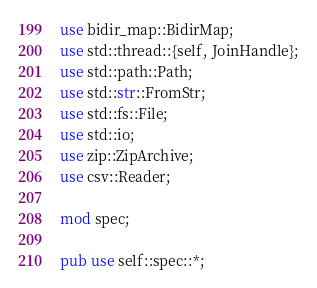Convert code to text. <code><loc_0><loc_0><loc_500><loc_500><_Rust_>use bidir_map::BidirMap;
use std::thread::{self, JoinHandle};
use std::path::Path;
use std::str::FromStr;
use std::fs::File;
use std::io;
use zip::ZipArchive;
use csv::Reader;

mod spec;

pub use self::spec::*;

</code> 